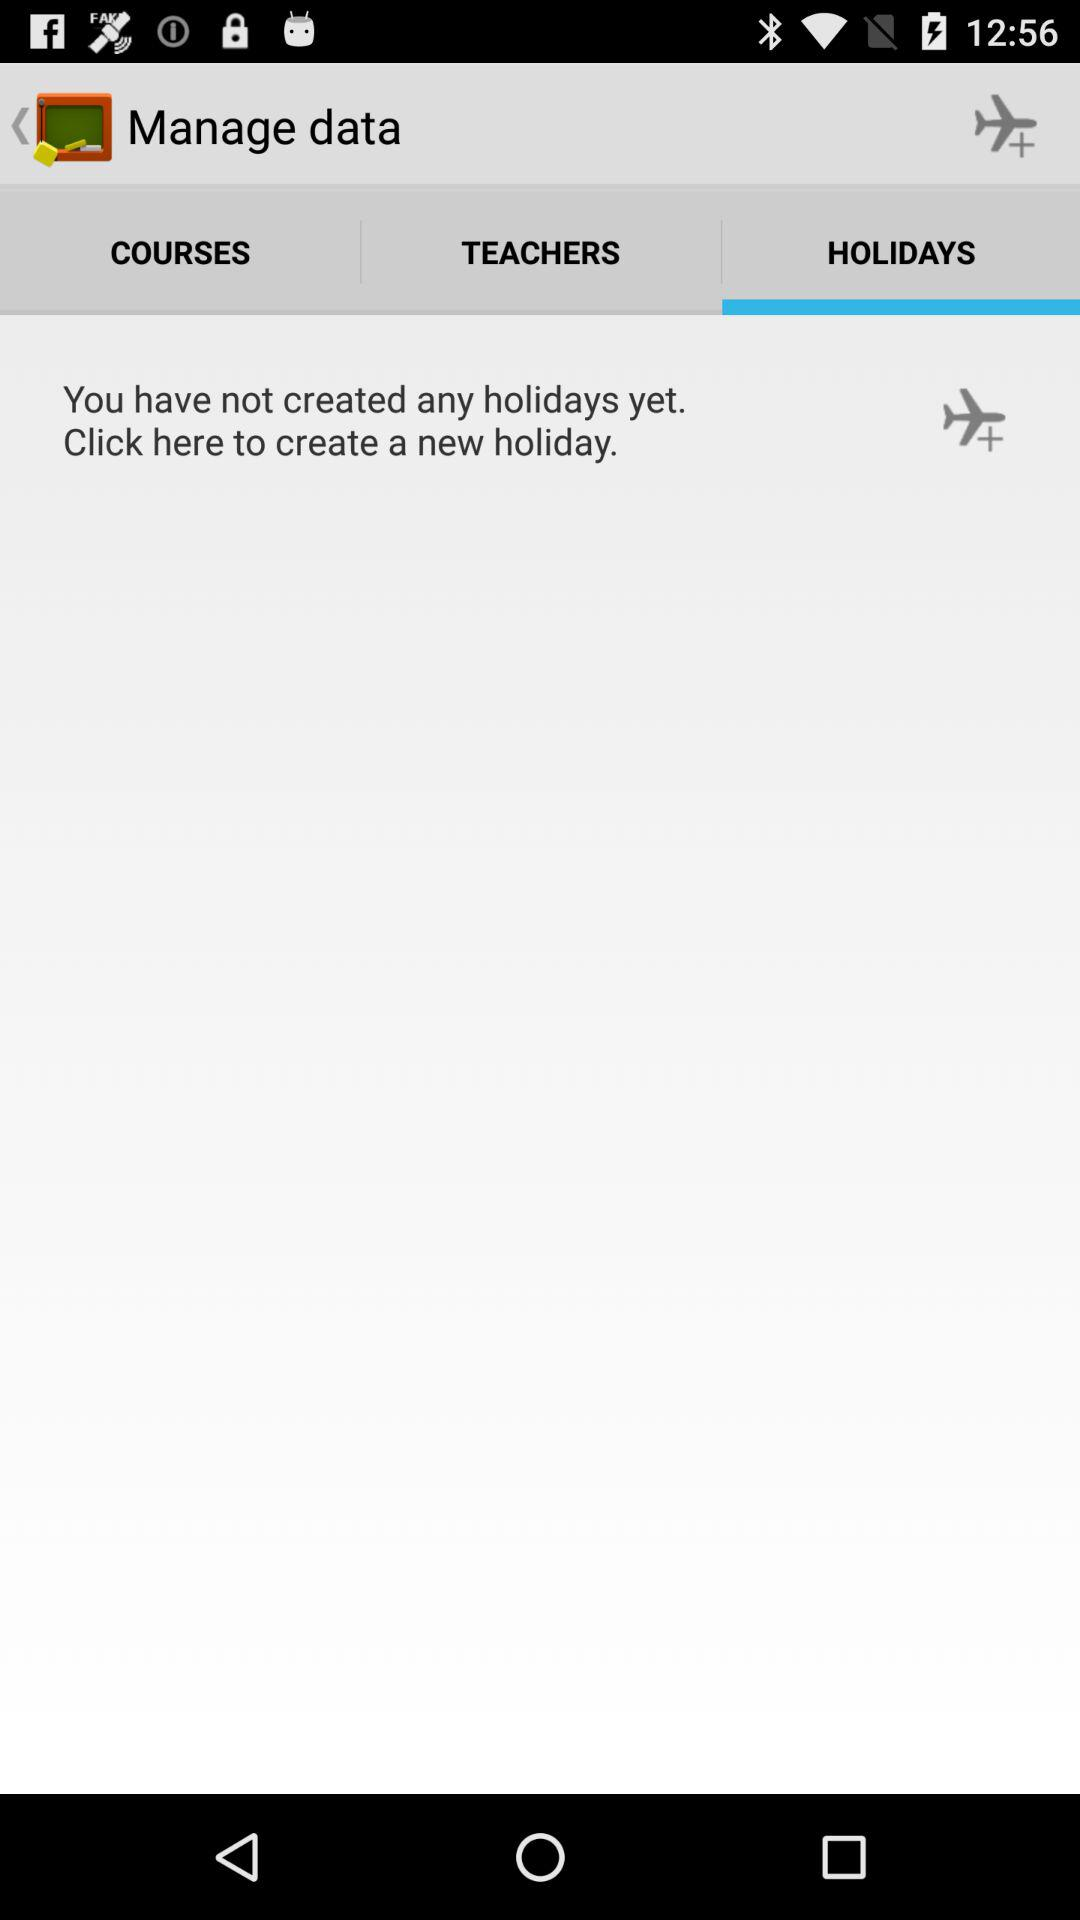How many holidays have been created?
Answer the question using a single word or phrase. 0 